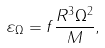<formula> <loc_0><loc_0><loc_500><loc_500>\varepsilon _ { \Omega } = f \frac { R ^ { 3 } \Omega ^ { 2 } } { M } ,</formula> 